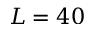<formula> <loc_0><loc_0><loc_500><loc_500>L = 4 0</formula> 